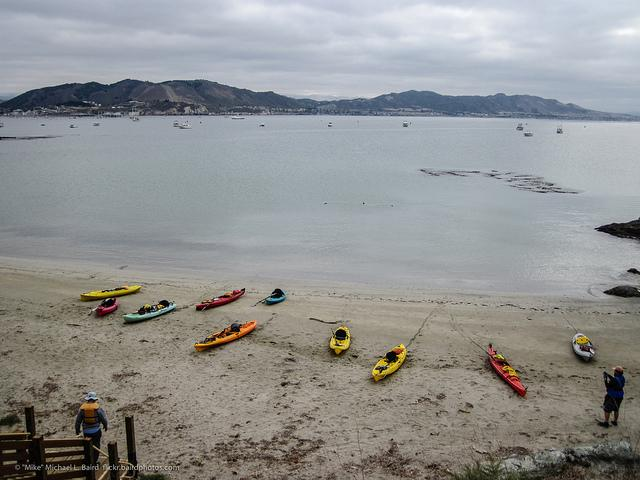What method do these vessels shown here normally gain movement? paddle 